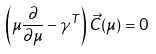<formula> <loc_0><loc_0><loc_500><loc_500>\left ( \mu \frac { \partial } { \partial \mu } - \gamma ^ { T } \right ) \vec { C } ( \mu ) = 0</formula> 